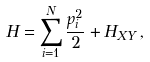<formula> <loc_0><loc_0><loc_500><loc_500>H = \sum _ { i = 1 } ^ { N } \frac { p _ { i } ^ { 2 } } { 2 } + H _ { X Y } \, ,</formula> 